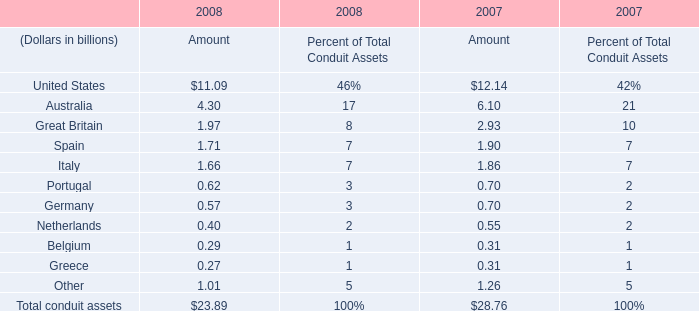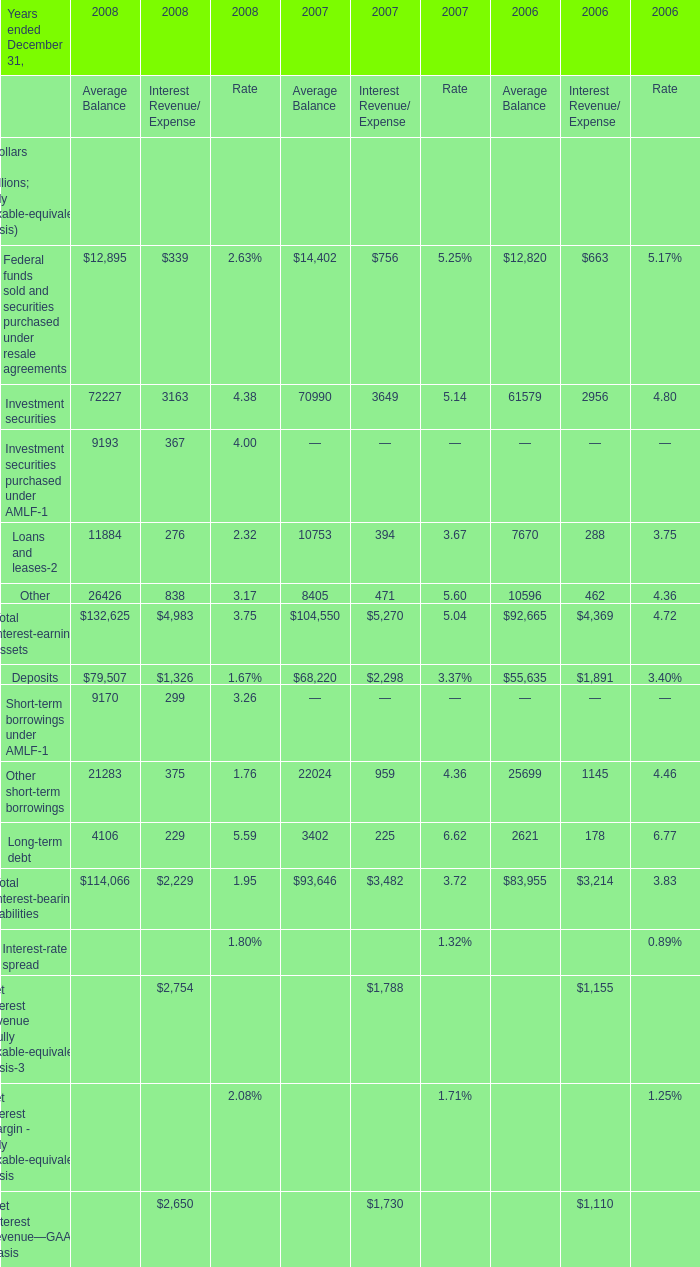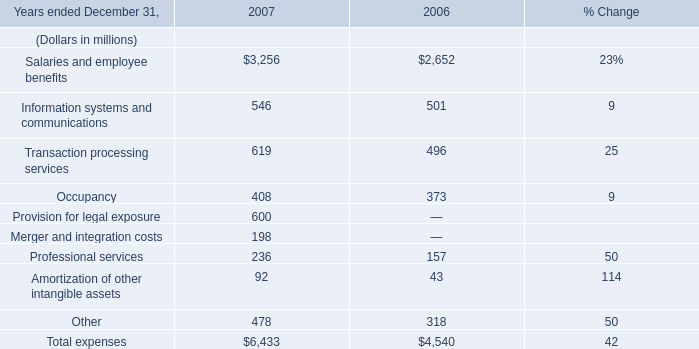As As the chart 1 shows, what is the Rate for the Net interest margin - fully taxable-equivalent basis for Year ended December 31,2007 ? 
Computations: (1.71 / 100)
Answer: 0.0171. 